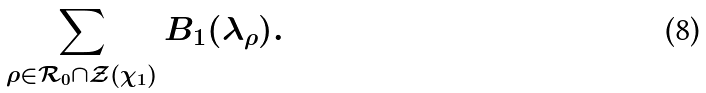Convert formula to latex. <formula><loc_0><loc_0><loc_500><loc_500>\sum _ { \rho \in \mathcal { R } _ { 0 } \cap \mathcal { Z } ( \chi _ { 1 } ) } B _ { 1 } ( \lambda _ { \rho } ) .</formula> 